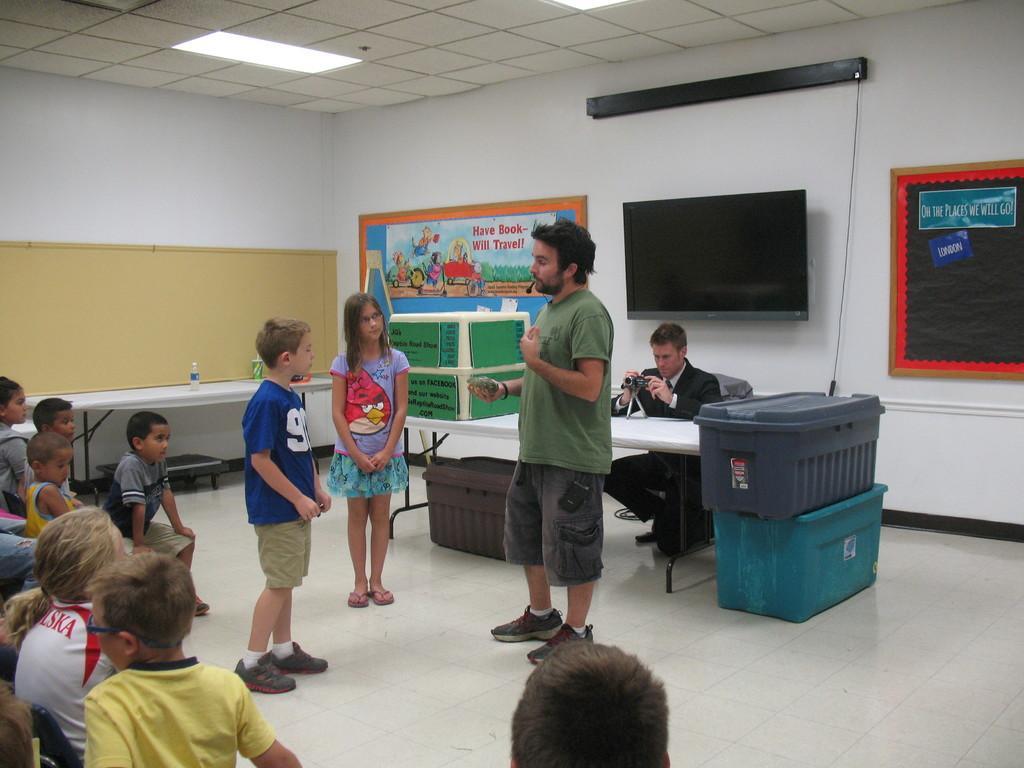How would you summarize this image in a sentence or two? In this picture we can see a group of people,here we can see a table,baskets and in the background we can see a television,posters,roof. 